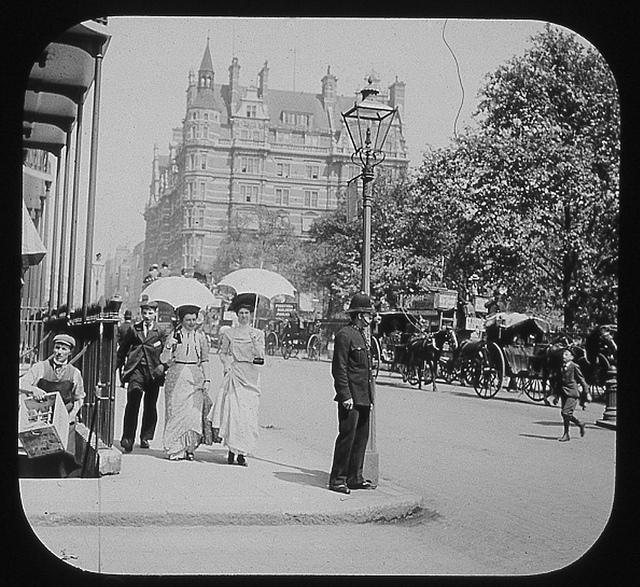What are the women on the left holding? Please explain your reasoning. umbrellas. The women have umbrellas. 